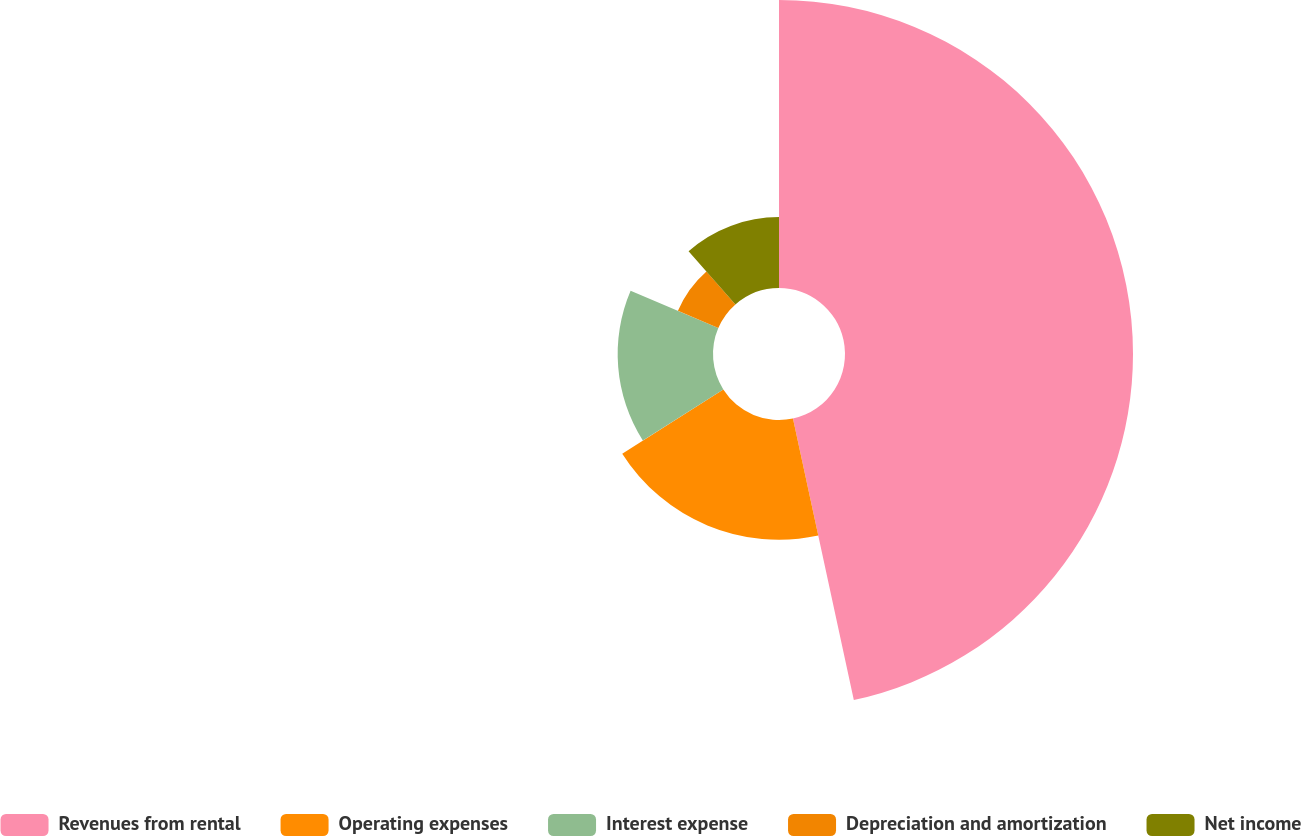Convert chart to OTSL. <chart><loc_0><loc_0><loc_500><loc_500><pie_chart><fcel>Revenues from rental<fcel>Operating expenses<fcel>Interest expense<fcel>Depreciation and amortization<fcel>Net income<nl><fcel>46.61%<fcel>19.38%<fcel>15.43%<fcel>7.1%<fcel>11.48%<nl></chart> 